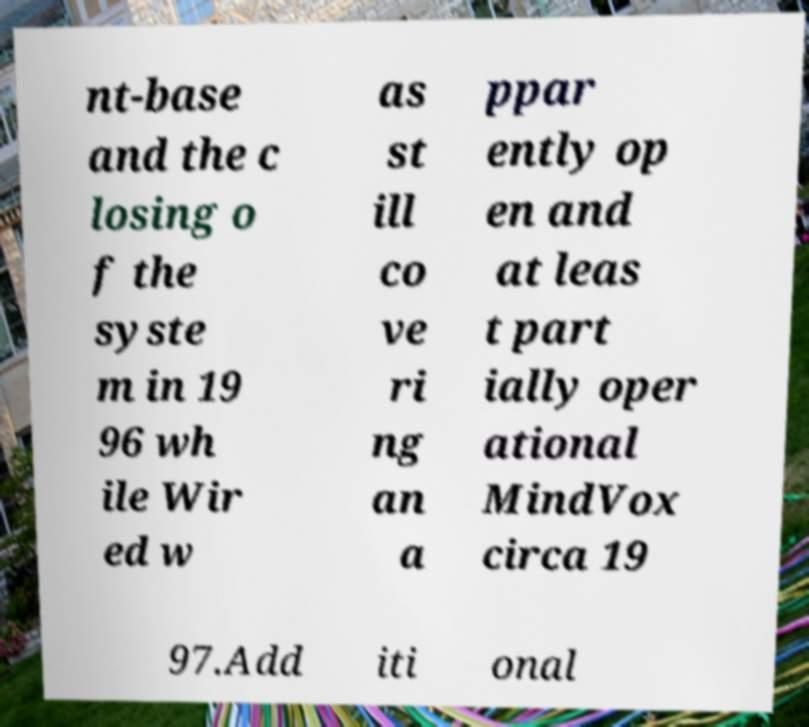What messages or text are displayed in this image? I need them in a readable, typed format. nt-base and the c losing o f the syste m in 19 96 wh ile Wir ed w as st ill co ve ri ng an a ppar ently op en and at leas t part ially oper ational MindVox circa 19 97.Add iti onal 